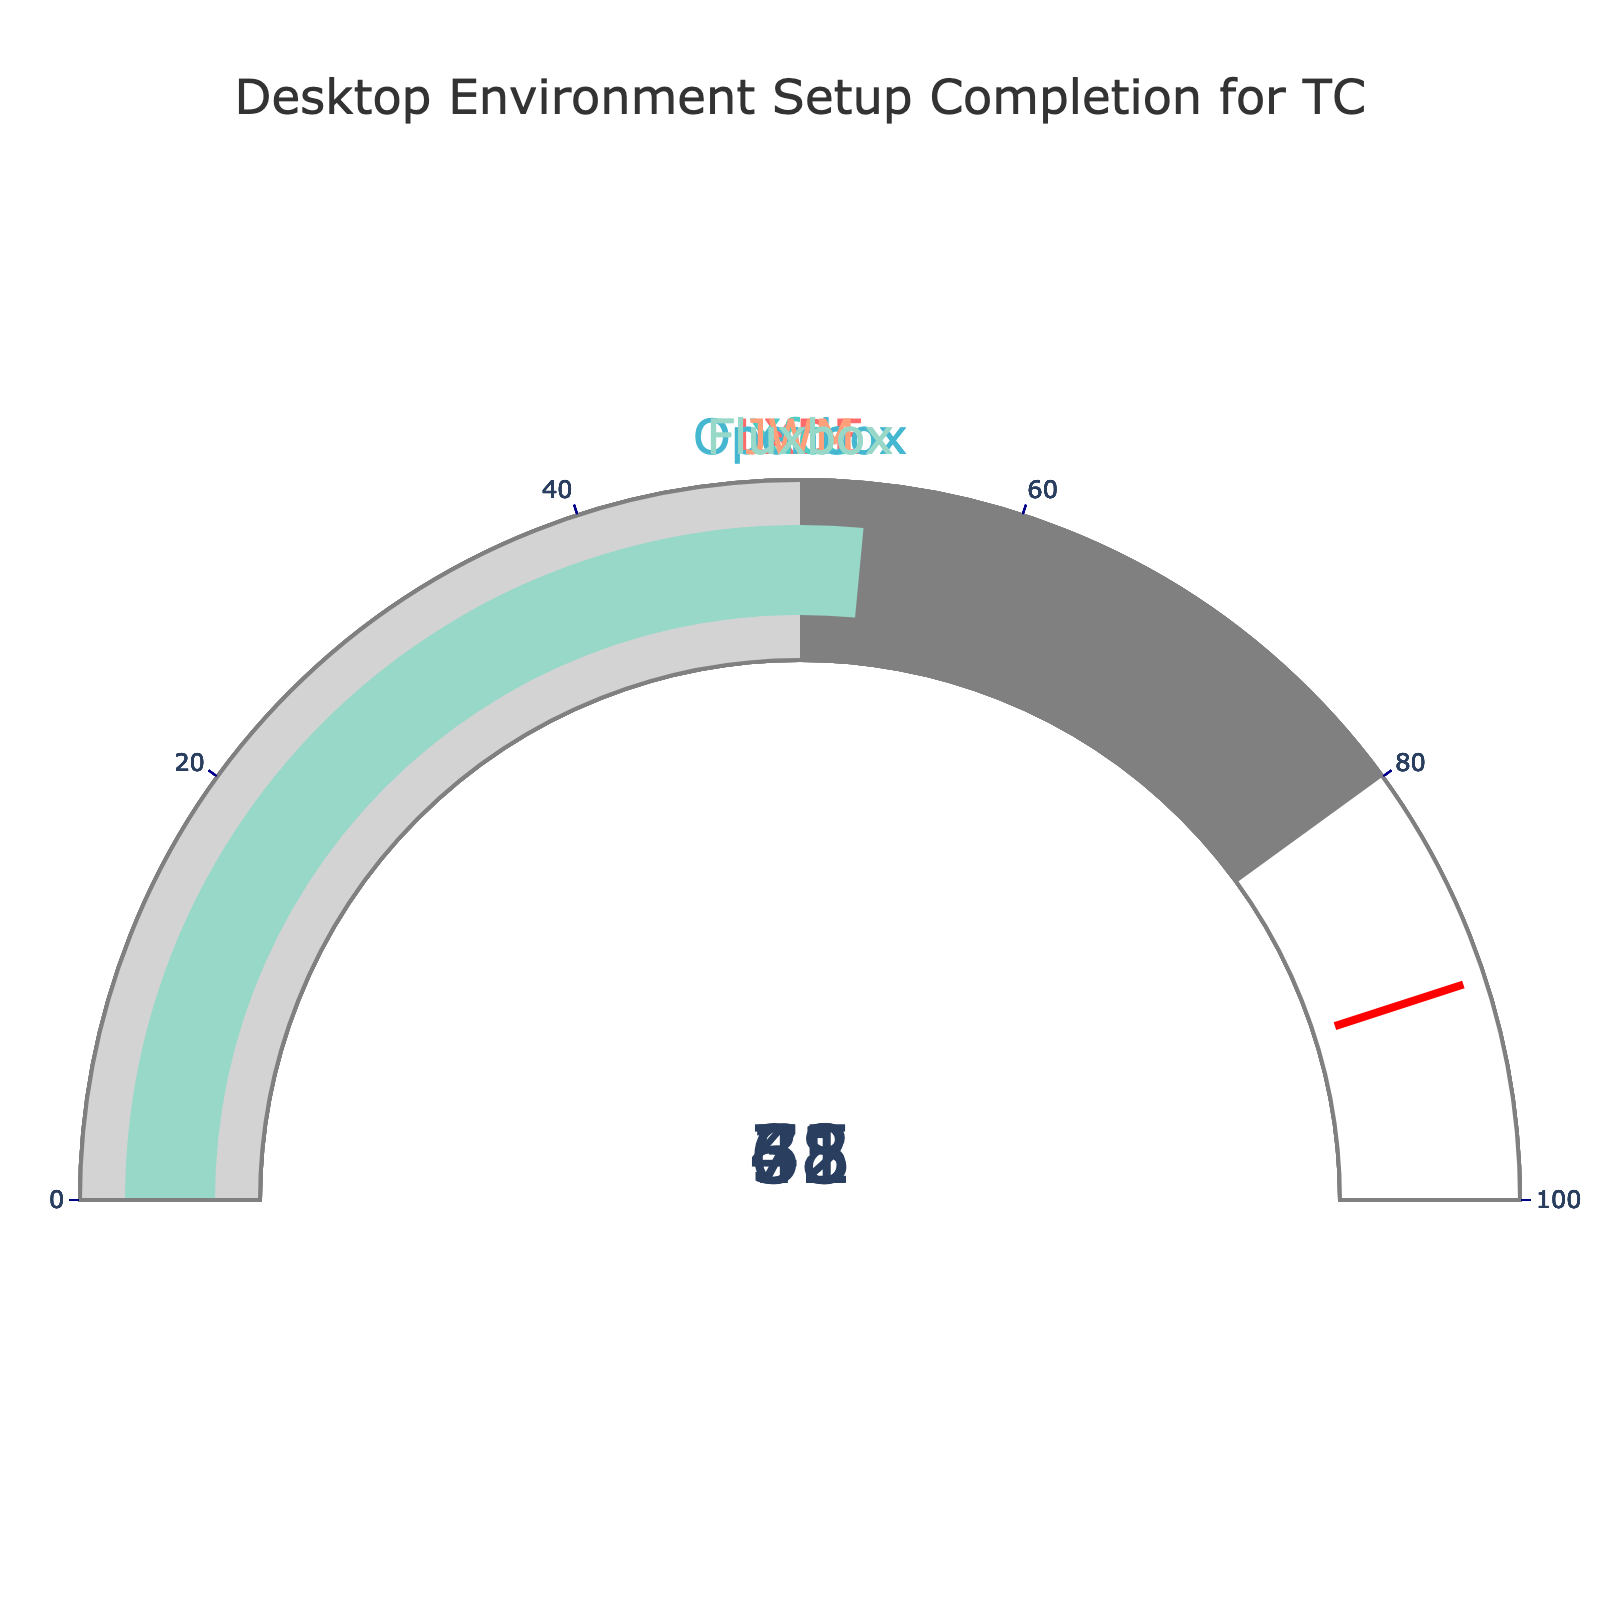how many desktop environments are shown in the figure? The figure contains one gauge for each desktop environment. By counting the gauges, we see there are five desktop environments represented.
Answer: 5 which desktop environment has the highest percentage of setup completion? By visually comparing the numbers on each gauge, we find that Openbox has the highest setup completion percentage at 78%.
Answer: Openbox compare the percentage completion of LXDE and JWM, which one is higher? By looking at the gauges, LXDE has a setup completion of 65%, while JWM has 31%. Therefore, LXDE has a higher percentage.
Answer: LXDE what is the average percentage completion of all desktop environments shown? Add all the percentages (65 + 42 + 78 + 31 + 53) and divide by the number of desktop environments (5). The calculation is (65 + 42 + 78 + 31 + 53) / 5 = 53.8.
Answer: 53.8 identify the desktop environment with the lowest setup completion percentage. By quickly scanning the gauges, JWM has the lowest setup completion percentage at 31%.
Answer: JWM what is the total percentage completion if you sum up all the desktop environments? Sum up all the percentages: 65 + 42 + 78 + 31 + 53 = 269.
Answer: 269 how much more completion percentage is needed for Openbox to reach 100%? Openbox is currently at 78%. To reach 100%, it needs 100 - 78 = 22%.
Answer: 22 what is the difference in percentage completion between Fluxbox and Xfce? Fluxbox has a completion of 53%, and Xfce has 42%. The difference is 53 - 42 = 11%.
Answer: 11 are any desktop environments within 10 percentage points of completing the setup? Checking the gauges, none of the desktop environments are within 10 percentage points, as the highest is Openbox at 78%, which is 22 percentage points away from 100%.
Answer: No does any desktop environment have a completion percentage in the range of 40% to 50%? Checking the percentages, Xfce falls within this range with a percentage completion of 42%.
Answer: Xfce 